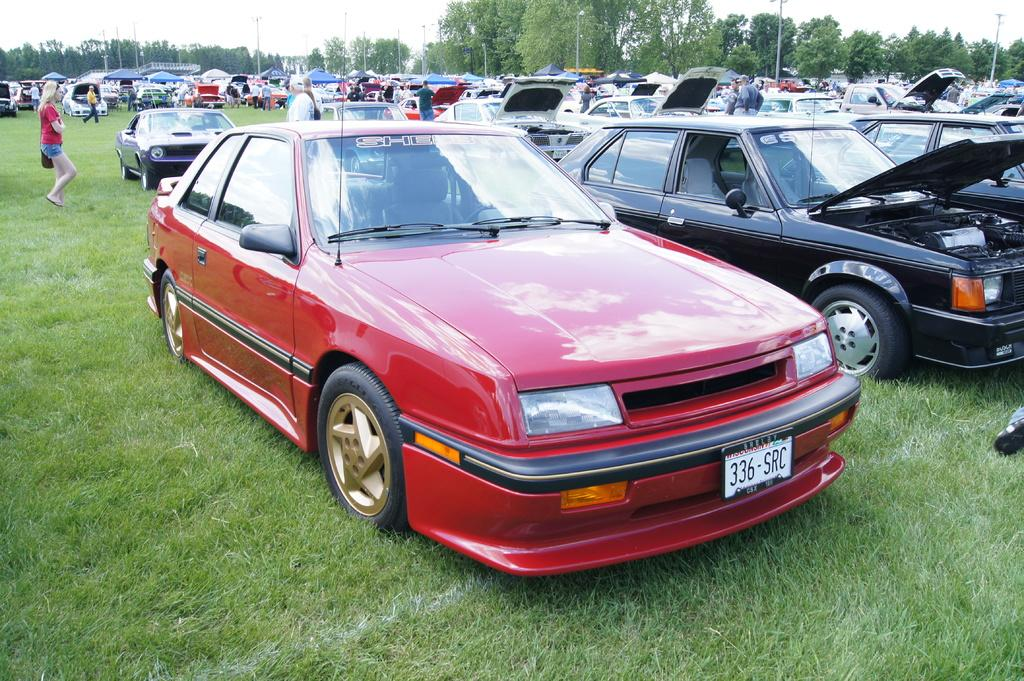What is the main subject of the image? The main subject of the image is many cars on the grass field. What else can be seen in the background of the image? There are men walking and trees present in the background. What is visible in the sky in the image? The sky is visible in the image. What type of lead is being used by the minister in the image? There is no minister or lead present in the image. What kind of apparatus is being used by the men walking in the background? The image does not show any apparatus being used by the men walking in the background. 